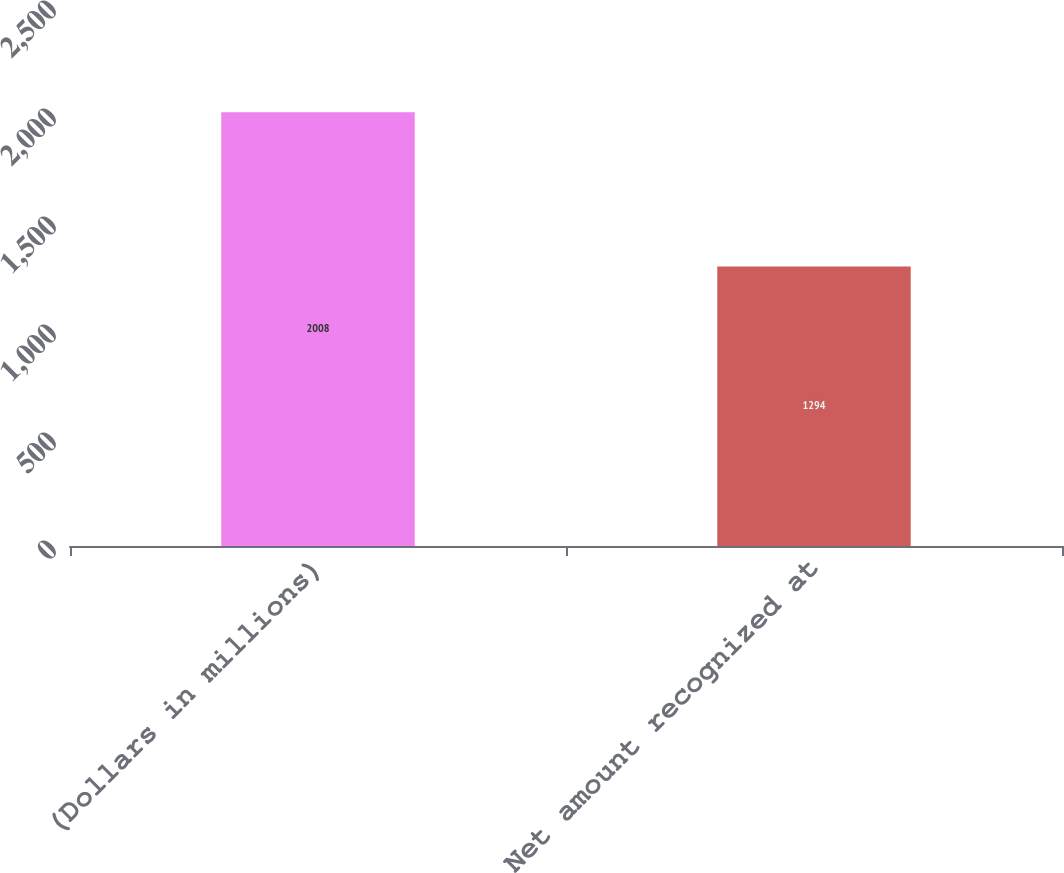Convert chart to OTSL. <chart><loc_0><loc_0><loc_500><loc_500><bar_chart><fcel>(Dollars in millions)<fcel>Net amount recognized at<nl><fcel>2008<fcel>1294<nl></chart> 